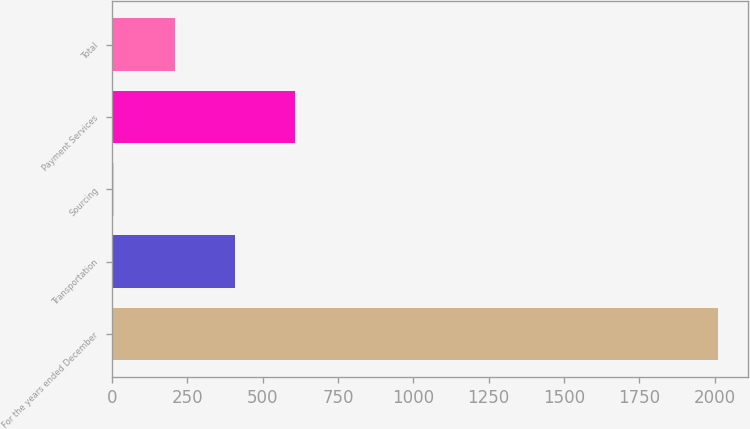<chart> <loc_0><loc_0><loc_500><loc_500><bar_chart><fcel>For the years ended December<fcel>Transportation<fcel>Sourcing<fcel>Payment Services<fcel>Total<nl><fcel>2010<fcel>408.8<fcel>8.5<fcel>608.95<fcel>208.65<nl></chart> 